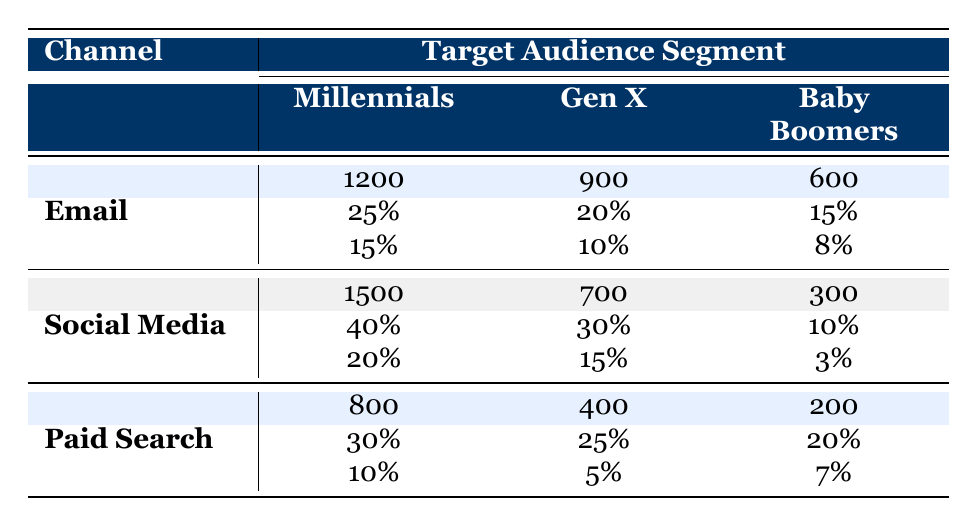What is the campaign reach for the Millennials via Social Media? The table shows that the campaign reach for Millennials through the Social Media channel is 1500.
Answer: 1500 What is the engagement rate for Baby Boomers in the Email channel? The table indicates that the engagement rate for Baby Boomers using the Email channel is 15%.
Answer: 15% How many more people were reached through the Email channel compared to the Paid Search channel for Gen X? The Email reach for Gen X is 900 and for Paid Search, it is 400. The difference is 900 - 400 = 500.
Answer: 500 What is the average conversion rate across all channels for Millennials? The conversion rates for Millennials are 15% (Email), 20% (Social Media), and 10% (Paid Search). The average is (15 + 20 + 10) / 3 = 15%.
Answer: 15% Is the conversion rate for Social Media among Baby Boomers greater than the conversion rate for Email? The conversion rate for Social Media for Baby Boomers is 3%, while the conversion rate for Email is 8%. Since 3% is less than 8%, the statement is false.
Answer: No Which channel has the highest engagement rate for Gen X? The engagement rates for Gen X are 20% (Email), 30% (Social Media), and 25% (Paid Search). Social Media has the highest at 30%.
Answer: Social Media What is the total campaign reach for the Paid Search channel across all target audience segments? The campaign reach for Paid Search is 800 (Millennials) + 400 (Gen X) + 200 (Baby Boomers) = 1400.
Answer: 1400 Does Email have a higher engagement rate for Millennials than Paid Search? The engagement rates are 25% for Email and 30% for Paid Search. Since 25% is less than 30%, the answer is no.
Answer: No What is the overall average reach across all channels for every target audience segment? The total reach is (1200 + 1500 + 800) + (900 + 700 + 400) + (600 + 300 + 200) = 5100, and there are 9 segments, so the average is 5100 / 9 = 566.67.
Answer: 566.67 